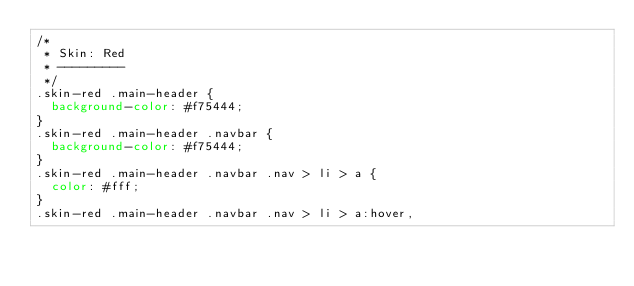Convert code to text. <code><loc_0><loc_0><loc_500><loc_500><_CSS_>/*
 * Skin: Red
 * ---------
 */
.skin-red .main-header {
  background-color: #f75444;
}
.skin-red .main-header .navbar {
  background-color: #f75444;
}
.skin-red .main-header .navbar .nav > li > a {
  color: #fff;
}
.skin-red .main-header .navbar .nav > li > a:hover,</code> 